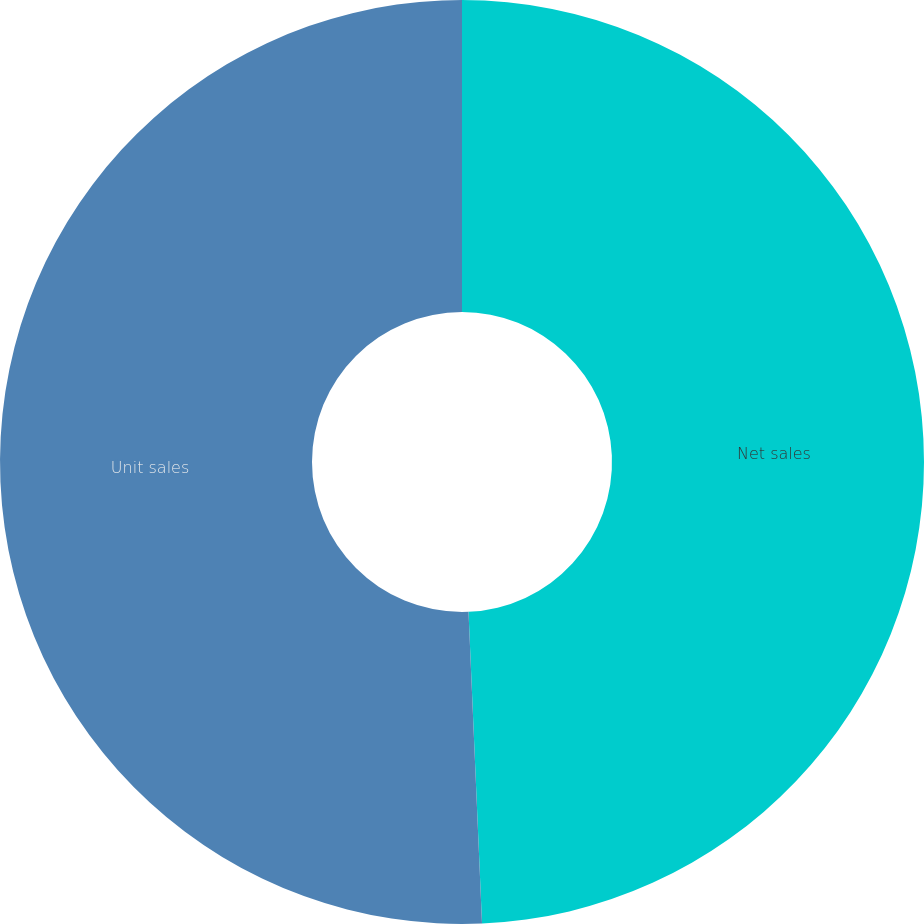<chart> <loc_0><loc_0><loc_500><loc_500><pie_chart><fcel>Net sales<fcel>Unit sales<nl><fcel>49.31%<fcel>50.69%<nl></chart> 